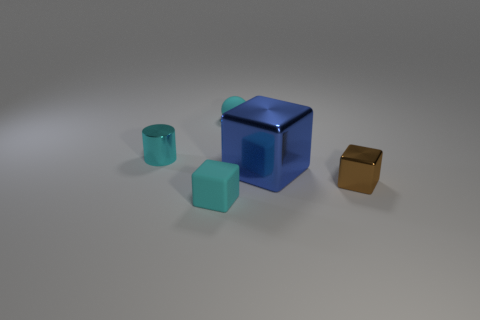There is a cyan object in front of the metal cylinder; what is its shape?
Provide a succinct answer. Cube. There is another cyan thing that is the same shape as the big thing; what is its material?
Provide a succinct answer. Rubber. There is a object behind the cyan metal object; is its size the same as the brown block?
Provide a succinct answer. Yes. How many big metallic blocks are to the left of the small cyan metal thing?
Your answer should be compact. 0. Are there fewer tiny matte objects that are in front of the small rubber sphere than things behind the small brown object?
Offer a terse response. Yes. How many tiny cyan metal things are there?
Provide a succinct answer. 1. There is a shiny thing in front of the big metallic object; what color is it?
Provide a succinct answer. Brown. How big is the metallic cylinder?
Keep it short and to the point. Small. Is the color of the tiny ball the same as the small shiny object that is left of the large metallic block?
Your answer should be compact. Yes. There is a tiny shiny object that is right of the cyan rubber object that is right of the cyan cube; what is its color?
Keep it short and to the point. Brown. 